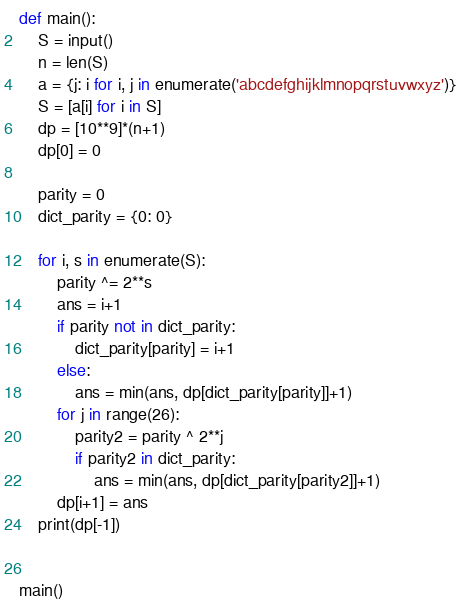<code> <loc_0><loc_0><loc_500><loc_500><_Python_>def main():
    S = input()
    n = len(S)
    a = {j: i for i, j in enumerate('abcdefghijklmnopqrstuvwxyz')}
    S = [a[i] for i in S]
    dp = [10**9]*(n+1)
    dp[0] = 0

    parity = 0
    dict_parity = {0: 0}

    for i, s in enumerate(S):
        parity ^= 2**s
        ans = i+1
        if parity not in dict_parity:
            dict_parity[parity] = i+1
        else:
            ans = min(ans, dp[dict_parity[parity]]+1)
        for j in range(26):
            parity2 = parity ^ 2**j
            if parity2 in dict_parity:
                ans = min(ans, dp[dict_parity[parity2]]+1)
        dp[i+1] = ans
    print(dp[-1])


main()</code> 